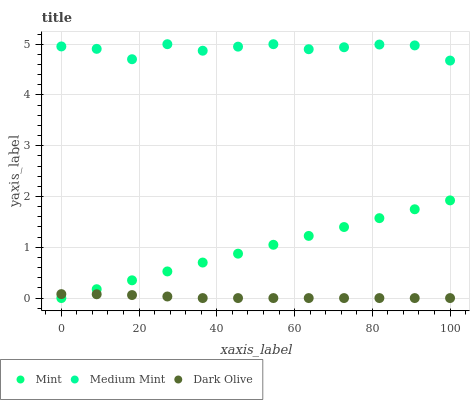Does Dark Olive have the minimum area under the curve?
Answer yes or no. Yes. Does Medium Mint have the maximum area under the curve?
Answer yes or no. Yes. Does Mint have the minimum area under the curve?
Answer yes or no. No. Does Mint have the maximum area under the curve?
Answer yes or no. No. Is Mint the smoothest?
Answer yes or no. Yes. Is Medium Mint the roughest?
Answer yes or no. Yes. Is Dark Olive the smoothest?
Answer yes or no. No. Is Dark Olive the roughest?
Answer yes or no. No. Does Dark Olive have the lowest value?
Answer yes or no. Yes. Does Medium Mint have the highest value?
Answer yes or no. Yes. Does Mint have the highest value?
Answer yes or no. No. Is Dark Olive less than Medium Mint?
Answer yes or no. Yes. Is Medium Mint greater than Dark Olive?
Answer yes or no. Yes. Does Dark Olive intersect Mint?
Answer yes or no. Yes. Is Dark Olive less than Mint?
Answer yes or no. No. Is Dark Olive greater than Mint?
Answer yes or no. No. Does Dark Olive intersect Medium Mint?
Answer yes or no. No. 